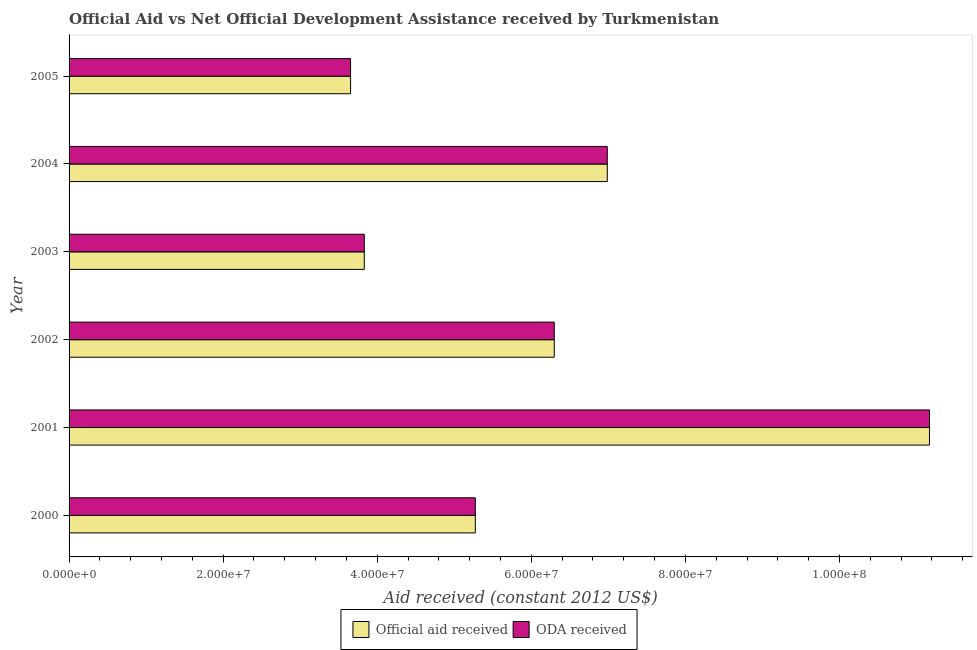How many different coloured bars are there?
Give a very brief answer. 2. How many groups of bars are there?
Your response must be concise. 6. How many bars are there on the 5th tick from the top?
Give a very brief answer. 2. How many bars are there on the 2nd tick from the bottom?
Ensure brevity in your answer.  2. What is the label of the 3rd group of bars from the top?
Give a very brief answer. 2003. What is the oda received in 2003?
Your answer should be very brief. 3.83e+07. Across all years, what is the maximum oda received?
Offer a terse response. 1.12e+08. Across all years, what is the minimum oda received?
Offer a terse response. 3.65e+07. In which year was the official aid received maximum?
Give a very brief answer. 2001. What is the total oda received in the graph?
Make the answer very short. 3.72e+08. What is the difference between the official aid received in 2000 and that in 2003?
Provide a succinct answer. 1.44e+07. What is the difference between the official aid received in 2002 and the oda received in 2001?
Ensure brevity in your answer.  -4.87e+07. What is the average oda received per year?
Offer a very short reply. 6.20e+07. In the year 2005, what is the difference between the official aid received and oda received?
Keep it short and to the point. 0. In how many years, is the oda received greater than 84000000 US$?
Give a very brief answer. 1. What is the ratio of the official aid received in 2001 to that in 2005?
Your answer should be very brief. 3.06. Is the oda received in 2000 less than that in 2004?
Give a very brief answer. Yes. What is the difference between the highest and the second highest official aid received?
Give a very brief answer. 4.18e+07. What is the difference between the highest and the lowest official aid received?
Ensure brevity in your answer.  7.51e+07. Is the sum of the official aid received in 2001 and 2004 greater than the maximum oda received across all years?
Provide a succinct answer. Yes. What does the 2nd bar from the top in 2001 represents?
Ensure brevity in your answer.  Official aid received. What does the 1st bar from the bottom in 2003 represents?
Make the answer very short. Official aid received. How many bars are there?
Make the answer very short. 12. Are all the bars in the graph horizontal?
Provide a short and direct response. Yes. How many years are there in the graph?
Your answer should be very brief. 6. What is the difference between two consecutive major ticks on the X-axis?
Make the answer very short. 2.00e+07. Are the values on the major ticks of X-axis written in scientific E-notation?
Your answer should be compact. Yes. Does the graph contain grids?
Your answer should be compact. No. Where does the legend appear in the graph?
Your answer should be compact. Bottom center. How are the legend labels stacked?
Offer a terse response. Horizontal. What is the title of the graph?
Provide a succinct answer. Official Aid vs Net Official Development Assistance received by Turkmenistan . What is the label or title of the X-axis?
Keep it short and to the point. Aid received (constant 2012 US$). What is the Aid received (constant 2012 US$) of Official aid received in 2000?
Your answer should be very brief. 5.27e+07. What is the Aid received (constant 2012 US$) in ODA received in 2000?
Provide a short and direct response. 5.27e+07. What is the Aid received (constant 2012 US$) of Official aid received in 2001?
Your answer should be very brief. 1.12e+08. What is the Aid received (constant 2012 US$) of ODA received in 2001?
Offer a terse response. 1.12e+08. What is the Aid received (constant 2012 US$) of Official aid received in 2002?
Make the answer very short. 6.30e+07. What is the Aid received (constant 2012 US$) of ODA received in 2002?
Provide a short and direct response. 6.30e+07. What is the Aid received (constant 2012 US$) in Official aid received in 2003?
Provide a short and direct response. 3.83e+07. What is the Aid received (constant 2012 US$) in ODA received in 2003?
Your answer should be very brief. 3.83e+07. What is the Aid received (constant 2012 US$) of Official aid received in 2004?
Offer a terse response. 6.99e+07. What is the Aid received (constant 2012 US$) of ODA received in 2004?
Ensure brevity in your answer.  6.99e+07. What is the Aid received (constant 2012 US$) of Official aid received in 2005?
Offer a very short reply. 3.65e+07. What is the Aid received (constant 2012 US$) in ODA received in 2005?
Make the answer very short. 3.65e+07. Across all years, what is the maximum Aid received (constant 2012 US$) in Official aid received?
Keep it short and to the point. 1.12e+08. Across all years, what is the maximum Aid received (constant 2012 US$) of ODA received?
Keep it short and to the point. 1.12e+08. Across all years, what is the minimum Aid received (constant 2012 US$) of Official aid received?
Your answer should be very brief. 3.65e+07. Across all years, what is the minimum Aid received (constant 2012 US$) in ODA received?
Make the answer very short. 3.65e+07. What is the total Aid received (constant 2012 US$) in Official aid received in the graph?
Offer a terse response. 3.72e+08. What is the total Aid received (constant 2012 US$) of ODA received in the graph?
Give a very brief answer. 3.72e+08. What is the difference between the Aid received (constant 2012 US$) of Official aid received in 2000 and that in 2001?
Your answer should be very brief. -5.90e+07. What is the difference between the Aid received (constant 2012 US$) in ODA received in 2000 and that in 2001?
Give a very brief answer. -5.90e+07. What is the difference between the Aid received (constant 2012 US$) in Official aid received in 2000 and that in 2002?
Your response must be concise. -1.02e+07. What is the difference between the Aid received (constant 2012 US$) of ODA received in 2000 and that in 2002?
Offer a very short reply. -1.02e+07. What is the difference between the Aid received (constant 2012 US$) in Official aid received in 2000 and that in 2003?
Give a very brief answer. 1.44e+07. What is the difference between the Aid received (constant 2012 US$) of ODA received in 2000 and that in 2003?
Offer a very short reply. 1.44e+07. What is the difference between the Aid received (constant 2012 US$) of Official aid received in 2000 and that in 2004?
Make the answer very short. -1.71e+07. What is the difference between the Aid received (constant 2012 US$) in ODA received in 2000 and that in 2004?
Your answer should be compact. -1.71e+07. What is the difference between the Aid received (constant 2012 US$) in Official aid received in 2000 and that in 2005?
Your answer should be compact. 1.62e+07. What is the difference between the Aid received (constant 2012 US$) of ODA received in 2000 and that in 2005?
Your answer should be very brief. 1.62e+07. What is the difference between the Aid received (constant 2012 US$) in Official aid received in 2001 and that in 2002?
Ensure brevity in your answer.  4.87e+07. What is the difference between the Aid received (constant 2012 US$) of ODA received in 2001 and that in 2002?
Give a very brief answer. 4.87e+07. What is the difference between the Aid received (constant 2012 US$) of Official aid received in 2001 and that in 2003?
Your answer should be compact. 7.34e+07. What is the difference between the Aid received (constant 2012 US$) of ODA received in 2001 and that in 2003?
Your answer should be very brief. 7.34e+07. What is the difference between the Aid received (constant 2012 US$) in Official aid received in 2001 and that in 2004?
Your answer should be compact. 4.18e+07. What is the difference between the Aid received (constant 2012 US$) of ODA received in 2001 and that in 2004?
Your answer should be compact. 4.18e+07. What is the difference between the Aid received (constant 2012 US$) of Official aid received in 2001 and that in 2005?
Keep it short and to the point. 7.51e+07. What is the difference between the Aid received (constant 2012 US$) in ODA received in 2001 and that in 2005?
Your answer should be compact. 7.51e+07. What is the difference between the Aid received (constant 2012 US$) in Official aid received in 2002 and that in 2003?
Your response must be concise. 2.47e+07. What is the difference between the Aid received (constant 2012 US$) of ODA received in 2002 and that in 2003?
Offer a terse response. 2.47e+07. What is the difference between the Aid received (constant 2012 US$) of Official aid received in 2002 and that in 2004?
Make the answer very short. -6.88e+06. What is the difference between the Aid received (constant 2012 US$) in ODA received in 2002 and that in 2004?
Give a very brief answer. -6.88e+06. What is the difference between the Aid received (constant 2012 US$) in Official aid received in 2002 and that in 2005?
Offer a very short reply. 2.64e+07. What is the difference between the Aid received (constant 2012 US$) of ODA received in 2002 and that in 2005?
Provide a short and direct response. 2.64e+07. What is the difference between the Aid received (constant 2012 US$) of Official aid received in 2003 and that in 2004?
Keep it short and to the point. -3.15e+07. What is the difference between the Aid received (constant 2012 US$) of ODA received in 2003 and that in 2004?
Ensure brevity in your answer.  -3.15e+07. What is the difference between the Aid received (constant 2012 US$) of Official aid received in 2003 and that in 2005?
Make the answer very short. 1.78e+06. What is the difference between the Aid received (constant 2012 US$) of ODA received in 2003 and that in 2005?
Provide a short and direct response. 1.78e+06. What is the difference between the Aid received (constant 2012 US$) of Official aid received in 2004 and that in 2005?
Make the answer very short. 3.33e+07. What is the difference between the Aid received (constant 2012 US$) in ODA received in 2004 and that in 2005?
Your response must be concise. 3.33e+07. What is the difference between the Aid received (constant 2012 US$) of Official aid received in 2000 and the Aid received (constant 2012 US$) of ODA received in 2001?
Give a very brief answer. -5.90e+07. What is the difference between the Aid received (constant 2012 US$) of Official aid received in 2000 and the Aid received (constant 2012 US$) of ODA received in 2002?
Offer a terse response. -1.02e+07. What is the difference between the Aid received (constant 2012 US$) in Official aid received in 2000 and the Aid received (constant 2012 US$) in ODA received in 2003?
Keep it short and to the point. 1.44e+07. What is the difference between the Aid received (constant 2012 US$) in Official aid received in 2000 and the Aid received (constant 2012 US$) in ODA received in 2004?
Offer a very short reply. -1.71e+07. What is the difference between the Aid received (constant 2012 US$) in Official aid received in 2000 and the Aid received (constant 2012 US$) in ODA received in 2005?
Offer a very short reply. 1.62e+07. What is the difference between the Aid received (constant 2012 US$) in Official aid received in 2001 and the Aid received (constant 2012 US$) in ODA received in 2002?
Ensure brevity in your answer.  4.87e+07. What is the difference between the Aid received (constant 2012 US$) of Official aid received in 2001 and the Aid received (constant 2012 US$) of ODA received in 2003?
Offer a very short reply. 7.34e+07. What is the difference between the Aid received (constant 2012 US$) of Official aid received in 2001 and the Aid received (constant 2012 US$) of ODA received in 2004?
Your answer should be very brief. 4.18e+07. What is the difference between the Aid received (constant 2012 US$) in Official aid received in 2001 and the Aid received (constant 2012 US$) in ODA received in 2005?
Provide a succinct answer. 7.51e+07. What is the difference between the Aid received (constant 2012 US$) in Official aid received in 2002 and the Aid received (constant 2012 US$) in ODA received in 2003?
Give a very brief answer. 2.47e+07. What is the difference between the Aid received (constant 2012 US$) of Official aid received in 2002 and the Aid received (constant 2012 US$) of ODA received in 2004?
Provide a succinct answer. -6.88e+06. What is the difference between the Aid received (constant 2012 US$) in Official aid received in 2002 and the Aid received (constant 2012 US$) in ODA received in 2005?
Offer a terse response. 2.64e+07. What is the difference between the Aid received (constant 2012 US$) of Official aid received in 2003 and the Aid received (constant 2012 US$) of ODA received in 2004?
Your answer should be compact. -3.15e+07. What is the difference between the Aid received (constant 2012 US$) of Official aid received in 2003 and the Aid received (constant 2012 US$) of ODA received in 2005?
Provide a succinct answer. 1.78e+06. What is the difference between the Aid received (constant 2012 US$) of Official aid received in 2004 and the Aid received (constant 2012 US$) of ODA received in 2005?
Your answer should be very brief. 3.33e+07. What is the average Aid received (constant 2012 US$) in Official aid received per year?
Your answer should be compact. 6.20e+07. What is the average Aid received (constant 2012 US$) of ODA received per year?
Provide a succinct answer. 6.20e+07. In the year 2001, what is the difference between the Aid received (constant 2012 US$) in Official aid received and Aid received (constant 2012 US$) in ODA received?
Keep it short and to the point. 0. In the year 2005, what is the difference between the Aid received (constant 2012 US$) in Official aid received and Aid received (constant 2012 US$) in ODA received?
Your answer should be very brief. 0. What is the ratio of the Aid received (constant 2012 US$) in Official aid received in 2000 to that in 2001?
Offer a terse response. 0.47. What is the ratio of the Aid received (constant 2012 US$) of ODA received in 2000 to that in 2001?
Provide a succinct answer. 0.47. What is the ratio of the Aid received (constant 2012 US$) in Official aid received in 2000 to that in 2002?
Provide a succinct answer. 0.84. What is the ratio of the Aid received (constant 2012 US$) in ODA received in 2000 to that in 2002?
Keep it short and to the point. 0.84. What is the ratio of the Aid received (constant 2012 US$) in Official aid received in 2000 to that in 2003?
Your response must be concise. 1.38. What is the ratio of the Aid received (constant 2012 US$) of ODA received in 2000 to that in 2003?
Keep it short and to the point. 1.38. What is the ratio of the Aid received (constant 2012 US$) of Official aid received in 2000 to that in 2004?
Give a very brief answer. 0.75. What is the ratio of the Aid received (constant 2012 US$) in ODA received in 2000 to that in 2004?
Provide a succinct answer. 0.75. What is the ratio of the Aid received (constant 2012 US$) of Official aid received in 2000 to that in 2005?
Provide a succinct answer. 1.44. What is the ratio of the Aid received (constant 2012 US$) of ODA received in 2000 to that in 2005?
Your answer should be compact. 1.44. What is the ratio of the Aid received (constant 2012 US$) in Official aid received in 2001 to that in 2002?
Keep it short and to the point. 1.77. What is the ratio of the Aid received (constant 2012 US$) of ODA received in 2001 to that in 2002?
Your answer should be very brief. 1.77. What is the ratio of the Aid received (constant 2012 US$) of Official aid received in 2001 to that in 2003?
Keep it short and to the point. 2.91. What is the ratio of the Aid received (constant 2012 US$) of ODA received in 2001 to that in 2003?
Give a very brief answer. 2.91. What is the ratio of the Aid received (constant 2012 US$) in Official aid received in 2001 to that in 2004?
Ensure brevity in your answer.  1.6. What is the ratio of the Aid received (constant 2012 US$) in ODA received in 2001 to that in 2004?
Your answer should be very brief. 1.6. What is the ratio of the Aid received (constant 2012 US$) of Official aid received in 2001 to that in 2005?
Your response must be concise. 3.06. What is the ratio of the Aid received (constant 2012 US$) of ODA received in 2001 to that in 2005?
Ensure brevity in your answer.  3.06. What is the ratio of the Aid received (constant 2012 US$) in Official aid received in 2002 to that in 2003?
Provide a short and direct response. 1.64. What is the ratio of the Aid received (constant 2012 US$) in ODA received in 2002 to that in 2003?
Offer a very short reply. 1.64. What is the ratio of the Aid received (constant 2012 US$) of Official aid received in 2002 to that in 2004?
Your answer should be compact. 0.9. What is the ratio of the Aid received (constant 2012 US$) of ODA received in 2002 to that in 2004?
Your answer should be very brief. 0.9. What is the ratio of the Aid received (constant 2012 US$) of Official aid received in 2002 to that in 2005?
Give a very brief answer. 1.72. What is the ratio of the Aid received (constant 2012 US$) of ODA received in 2002 to that in 2005?
Your response must be concise. 1.72. What is the ratio of the Aid received (constant 2012 US$) in Official aid received in 2003 to that in 2004?
Give a very brief answer. 0.55. What is the ratio of the Aid received (constant 2012 US$) of ODA received in 2003 to that in 2004?
Give a very brief answer. 0.55. What is the ratio of the Aid received (constant 2012 US$) in Official aid received in 2003 to that in 2005?
Keep it short and to the point. 1.05. What is the ratio of the Aid received (constant 2012 US$) of ODA received in 2003 to that in 2005?
Make the answer very short. 1.05. What is the ratio of the Aid received (constant 2012 US$) of Official aid received in 2004 to that in 2005?
Provide a short and direct response. 1.91. What is the ratio of the Aid received (constant 2012 US$) of ODA received in 2004 to that in 2005?
Your answer should be very brief. 1.91. What is the difference between the highest and the second highest Aid received (constant 2012 US$) in Official aid received?
Make the answer very short. 4.18e+07. What is the difference between the highest and the second highest Aid received (constant 2012 US$) in ODA received?
Your answer should be very brief. 4.18e+07. What is the difference between the highest and the lowest Aid received (constant 2012 US$) in Official aid received?
Ensure brevity in your answer.  7.51e+07. What is the difference between the highest and the lowest Aid received (constant 2012 US$) in ODA received?
Give a very brief answer. 7.51e+07. 